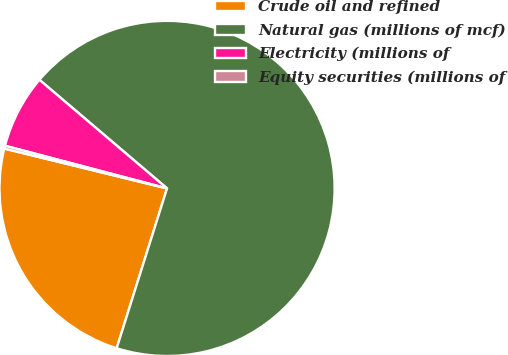Convert chart. <chart><loc_0><loc_0><loc_500><loc_500><pie_chart><fcel>Crude oil and refined<fcel>Natural gas (millions of mcf)<fcel>Electricity (millions of<fcel>Equity securities (millions of<nl><fcel>23.96%<fcel>68.63%<fcel>7.12%<fcel>0.28%<nl></chart> 